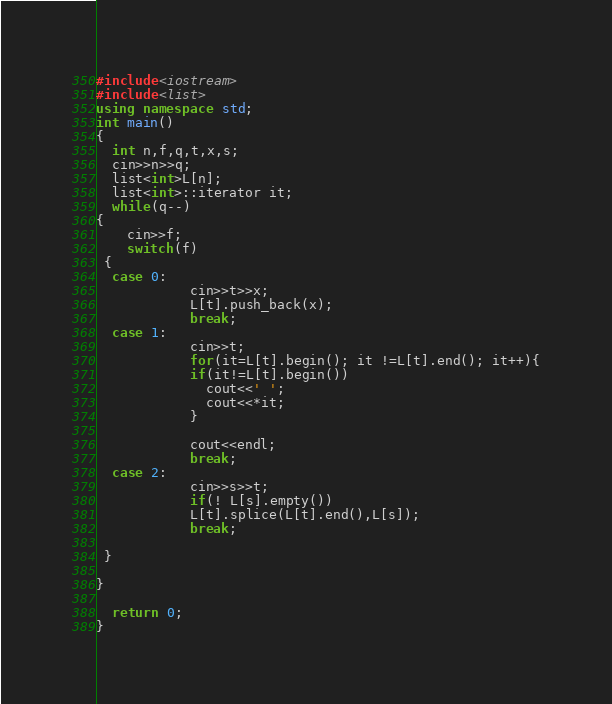Convert code to text. <code><loc_0><loc_0><loc_500><loc_500><_C++_>#include<iostream>
#include<list>
using namespace std;
int main()
{
  int n,f,q,t,x,s;
  cin>>n>>q;
  list<int>L[n];
  list<int>::iterator it;
  while(q--)
{
    cin>>f;
    switch(f)
 {
  case 0:
            cin>>t>>x;
            L[t].push_back(x);
            break;
  case 1:
            cin>>t;
            for(it=L[t].begin(); it !=L[t].end(); it++){
            if(it!=L[t].begin())
              cout<<' ';
              cout<<*it;
            }

            cout<<endl;
            break;
  case 2:
            cin>>s>>t;
            if(! L[s].empty())
            L[t].splice(L[t].end(),L[s]);
            break;

 }

}

  return 0;
}

</code> 